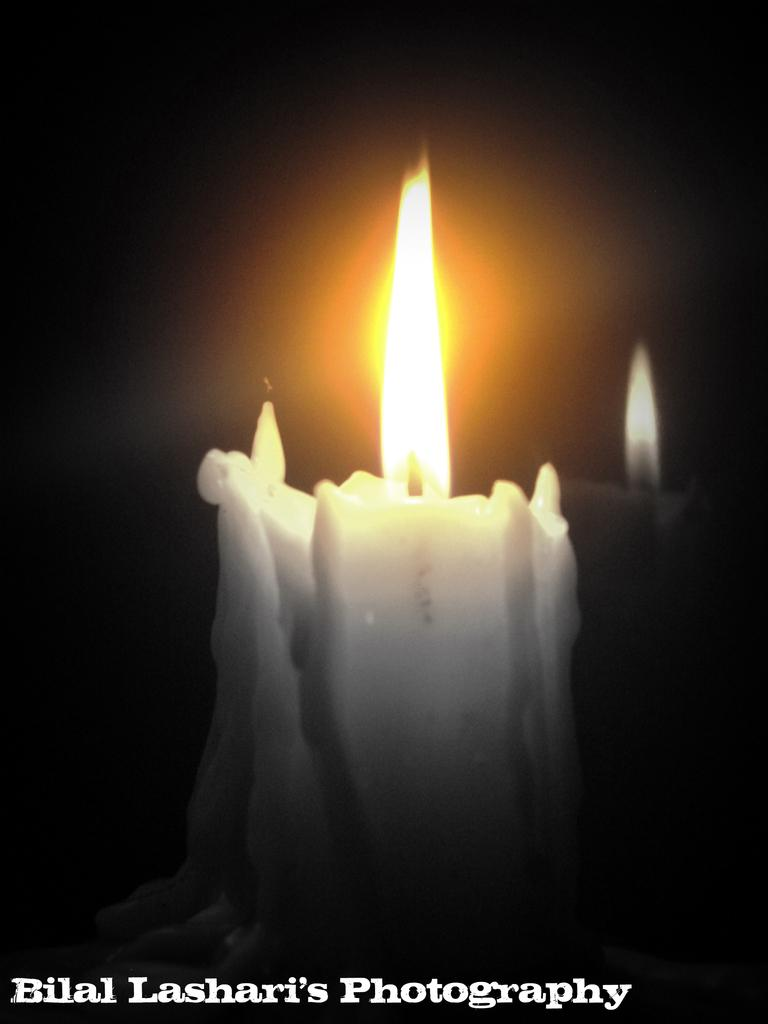What is the main object in the center of the image? There is a candle in the center of the image. Is there any text present in the image? Yes, there is text at the bottom side of the image. What type of account does the goose have in the image? There is no goose present in the image, so it cannot have an account. 